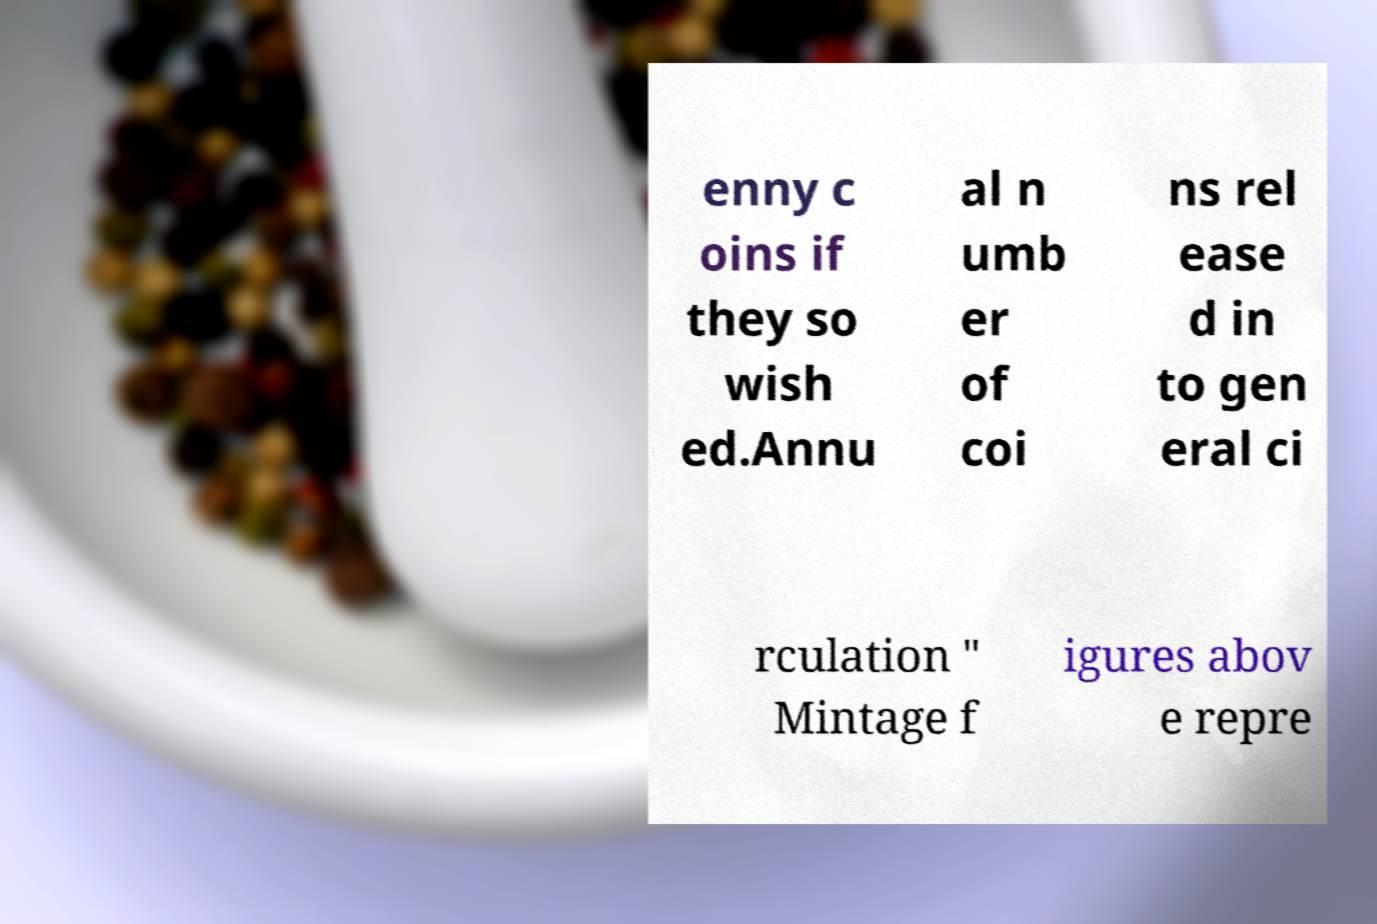Please read and relay the text visible in this image. What does it say? enny c oins if they so wish ed.Annu al n umb er of coi ns rel ease d in to gen eral ci rculation " Mintage f igures abov e repre 